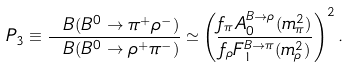Convert formula to latex. <formula><loc_0><loc_0><loc_500><loc_500>P _ { 3 } \equiv \frac { \ B ( B ^ { 0 } \to \pi ^ { + } \rho ^ { - } ) } { \ B ( B ^ { 0 } \to \rho ^ { + } \pi ^ { - } ) } \simeq \left ( \frac { f _ { \pi } A _ { 0 } ^ { B \to \rho } ( m _ { \pi } ^ { 2 } ) } { f _ { \rho } F _ { 1 } ^ { B \to \pi } ( m _ { \rho } ^ { 2 } ) } \right ) ^ { 2 } .</formula> 